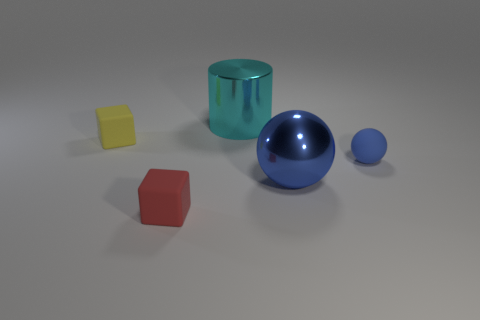What number of things are large gray metallic cylinders or small objects in front of the big blue object?
Offer a very short reply. 1. Are there fewer large cyan metallic cylinders in front of the yellow matte object than matte objects that are in front of the shiny cylinder?
Ensure brevity in your answer.  Yes. How many other things are there of the same material as the large cyan object?
Make the answer very short. 1. Is the color of the shiny thing that is behind the small yellow thing the same as the large sphere?
Make the answer very short. No. There is a small matte block that is in front of the tiny blue rubber object; are there any large shiny things behind it?
Give a very brief answer. Yes. What is the material of the thing that is behind the tiny blue matte ball and to the right of the tiny yellow cube?
Offer a terse response. Metal. There is a tiny blue thing that is the same material as the red thing; what is its shape?
Make the answer very short. Sphere. Is there any other thing that is the same shape as the large cyan thing?
Provide a short and direct response. No. Are the tiny cube that is to the left of the red rubber thing and the big cyan cylinder made of the same material?
Offer a very short reply. No. There is a tiny object that is right of the cyan cylinder; what is it made of?
Keep it short and to the point. Rubber. 